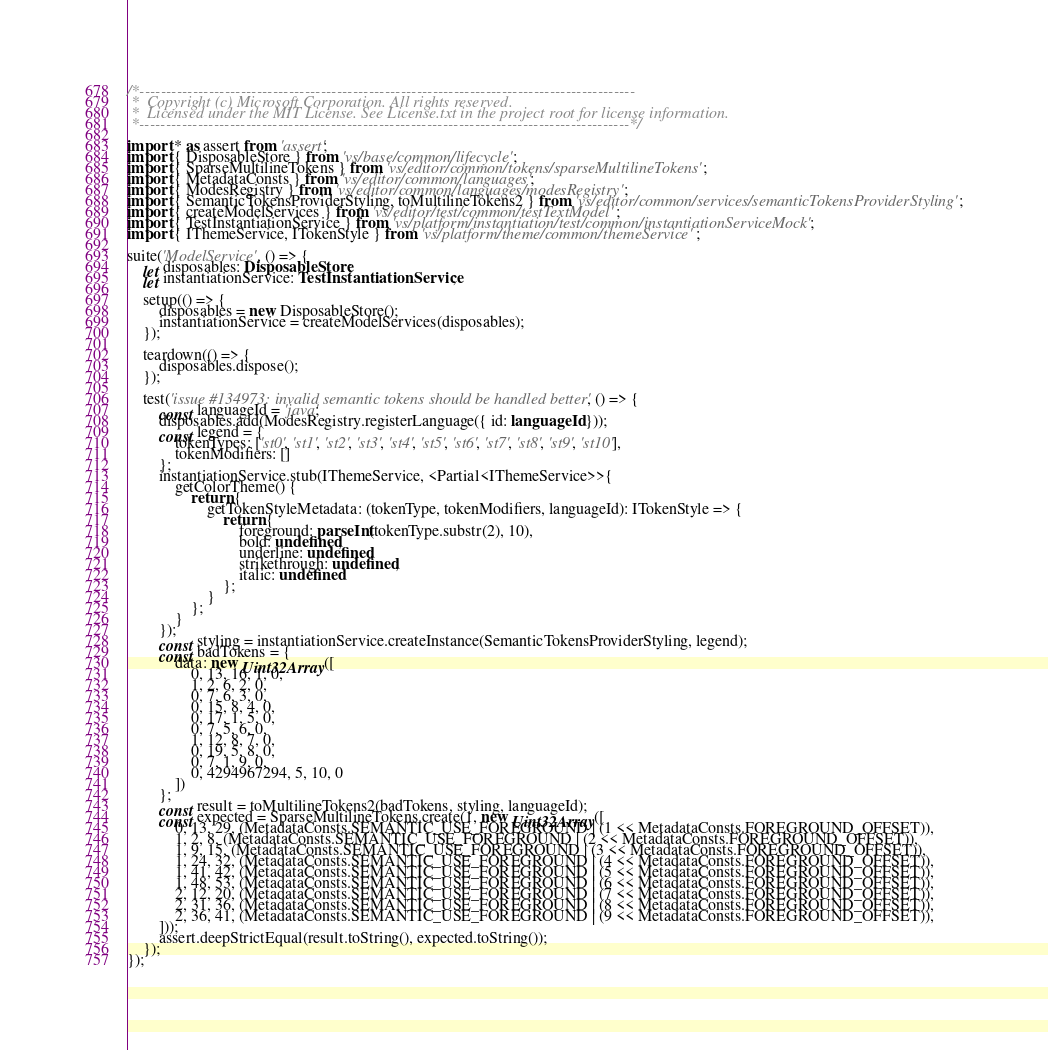<code> <loc_0><loc_0><loc_500><loc_500><_TypeScript_>/*---------------------------------------------------------------------------------------------
 *  Copyright (c) Microsoft Corporation. All rights reserved.
 *  Licensed under the MIT License. See License.txt in the project root for license information.
 *--------------------------------------------------------------------------------------------*/

import * as assert from 'assert';
import { DisposableStore } from 'vs/base/common/lifecycle';
import { SparseMultilineTokens } from 'vs/editor/common/tokens/sparseMultilineTokens';
import { MetadataConsts } from 'vs/editor/common/languages';
import { ModesRegistry } from 'vs/editor/common/languages/modesRegistry';
import { SemanticTokensProviderStyling, toMultilineTokens2 } from 'vs/editor/common/services/semanticTokensProviderStyling';
import { createModelServices } from 'vs/editor/test/common/testTextModel';
import { TestInstantiationService } from 'vs/platform/instantiation/test/common/instantiationServiceMock';
import { IThemeService, ITokenStyle } from 'vs/platform/theme/common/themeService';

suite('ModelService', () => {
	let disposables: DisposableStore;
	let instantiationService: TestInstantiationService;

	setup(() => {
		disposables = new DisposableStore();
		instantiationService = createModelServices(disposables);
	});

	teardown(() => {
		disposables.dispose();
	});

	test('issue #134973: invalid semantic tokens should be handled better', () => {
		const languageId = 'java';
		disposables.add(ModesRegistry.registerLanguage({ id: languageId }));
		const legend = {
			tokenTypes: ['st0', 'st1', 'st2', 'st3', 'st4', 'st5', 'st6', 'st7', 'st8', 'st9', 'st10'],
			tokenModifiers: []
		};
		instantiationService.stub(IThemeService, <Partial<IThemeService>>{
			getColorTheme() {
				return {
					getTokenStyleMetadata: (tokenType, tokenModifiers, languageId): ITokenStyle => {
						return {
							foreground: parseInt(tokenType.substr(2), 10),
							bold: undefined,
							underline: undefined,
							strikethrough: undefined,
							italic: undefined
						};
					}
				};
			}
		});
		const styling = instantiationService.createInstance(SemanticTokensProviderStyling, legend);
		const badTokens = {
			data: new Uint32Array([
				0, 13, 16, 1, 0,
				1, 2, 6, 2, 0,
				0, 7, 6, 3, 0,
				0, 15, 8, 4, 0,
				0, 17, 1, 5, 0,
				0, 7, 5, 6, 0,
				1, 12, 8, 7, 0,
				0, 19, 5, 8, 0,
				0, 7, 1, 9, 0,
				0, 4294967294, 5, 10, 0
			])
		};
		const result = toMultilineTokens2(badTokens, styling, languageId);
		const expected = SparseMultilineTokens.create(1, new Uint32Array([
			0, 13, 29, (MetadataConsts.SEMANTIC_USE_FOREGROUND | (1 << MetadataConsts.FOREGROUND_OFFSET)),
			1, 2, 8, (MetadataConsts.SEMANTIC_USE_FOREGROUND | (2 << MetadataConsts.FOREGROUND_OFFSET)),
			1, 9, 15, (MetadataConsts.SEMANTIC_USE_FOREGROUND | (3 << MetadataConsts.FOREGROUND_OFFSET)),
			1, 24, 32, (MetadataConsts.SEMANTIC_USE_FOREGROUND | (4 << MetadataConsts.FOREGROUND_OFFSET)),
			1, 41, 42, (MetadataConsts.SEMANTIC_USE_FOREGROUND | (5 << MetadataConsts.FOREGROUND_OFFSET)),
			1, 48, 53, (MetadataConsts.SEMANTIC_USE_FOREGROUND | (6 << MetadataConsts.FOREGROUND_OFFSET)),
			2, 12, 20, (MetadataConsts.SEMANTIC_USE_FOREGROUND | (7 << MetadataConsts.FOREGROUND_OFFSET)),
			2, 31, 36, (MetadataConsts.SEMANTIC_USE_FOREGROUND | (8 << MetadataConsts.FOREGROUND_OFFSET)),
			2, 36, 41, (MetadataConsts.SEMANTIC_USE_FOREGROUND | (9 << MetadataConsts.FOREGROUND_OFFSET)),
		]));
		assert.deepStrictEqual(result.toString(), expected.toString());
	});
});
</code> 